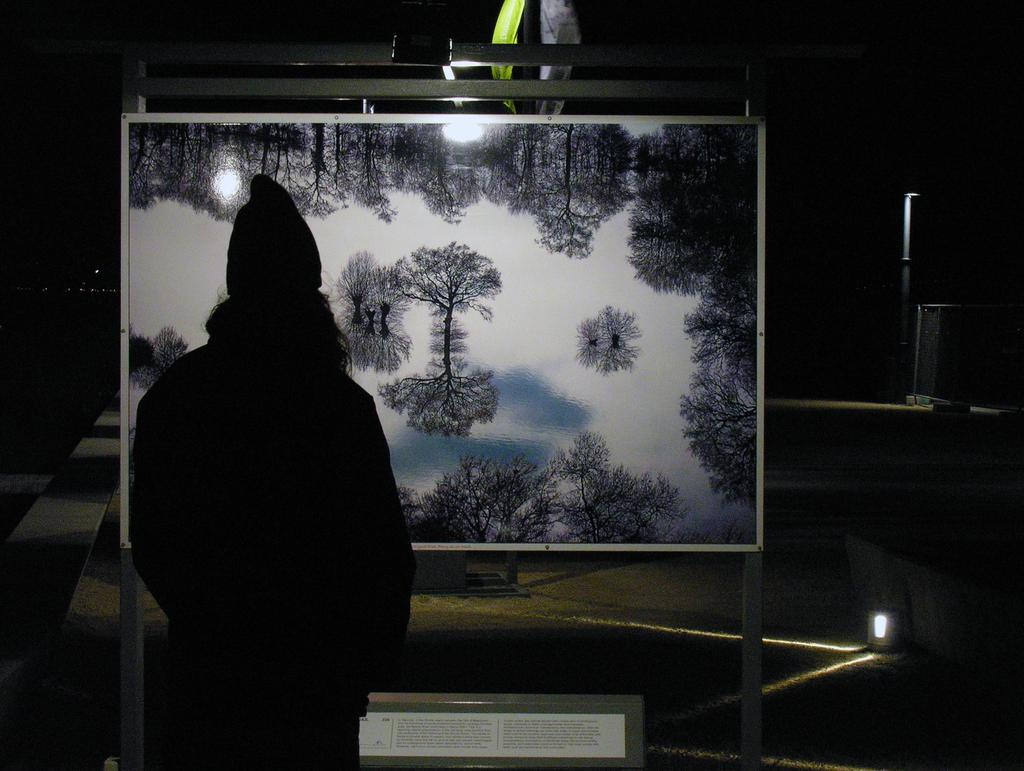Who or what is in the image? There is a person in the image. What is the person doing or standing in front of? The person is standing in front of a screen. What can be seen on the screen? The screen displays trees and plants. Can you describe the lighting in the image? There is a light source visible to the side of the person. What type of car is visible on the canvas in the image? There is no car or canvas present in the image. The image features a person standing in front of a screen displaying trees and plants, with a light source visible to the side. 